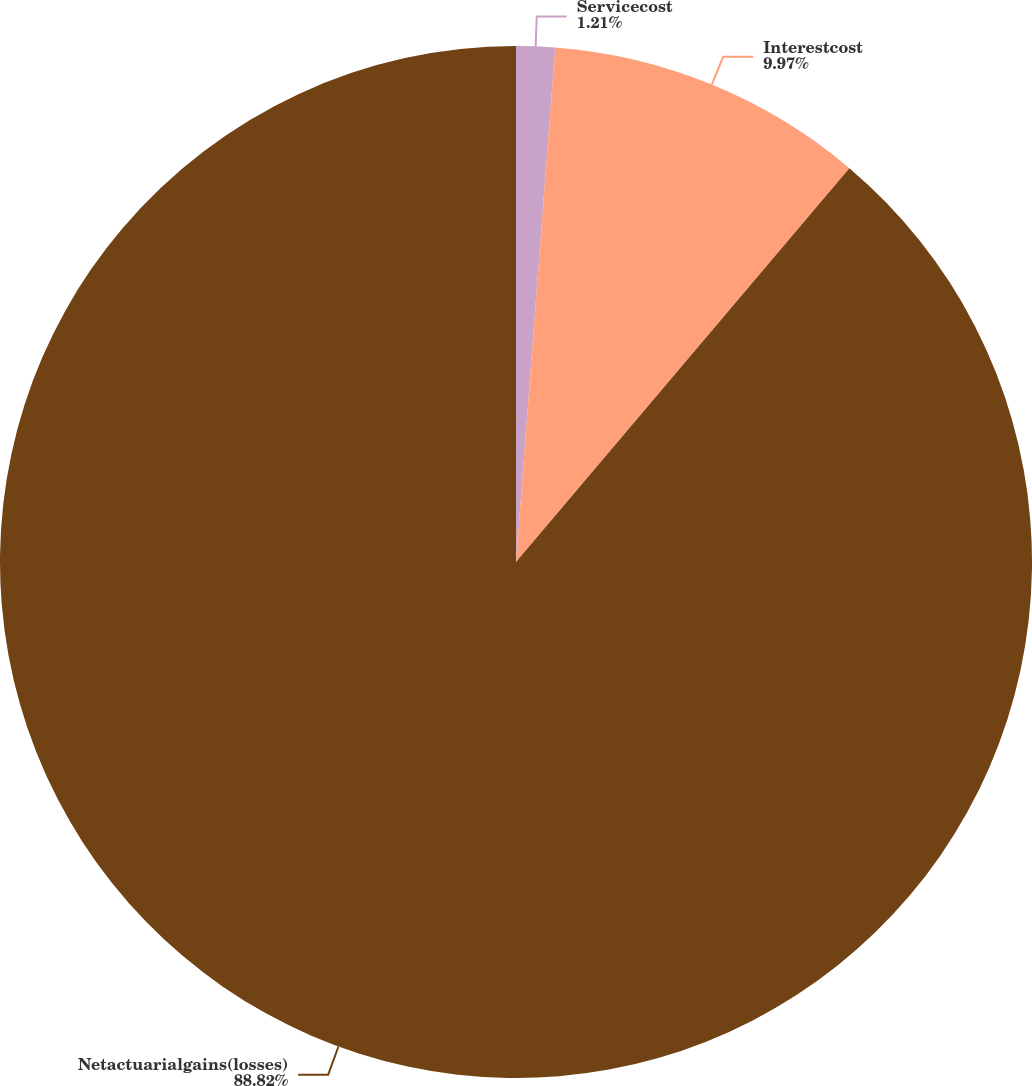Convert chart to OTSL. <chart><loc_0><loc_0><loc_500><loc_500><pie_chart><fcel>Servicecost<fcel>Interestcost<fcel>Netactuarialgains(losses)<nl><fcel>1.21%<fcel>9.97%<fcel>88.83%<nl></chart> 